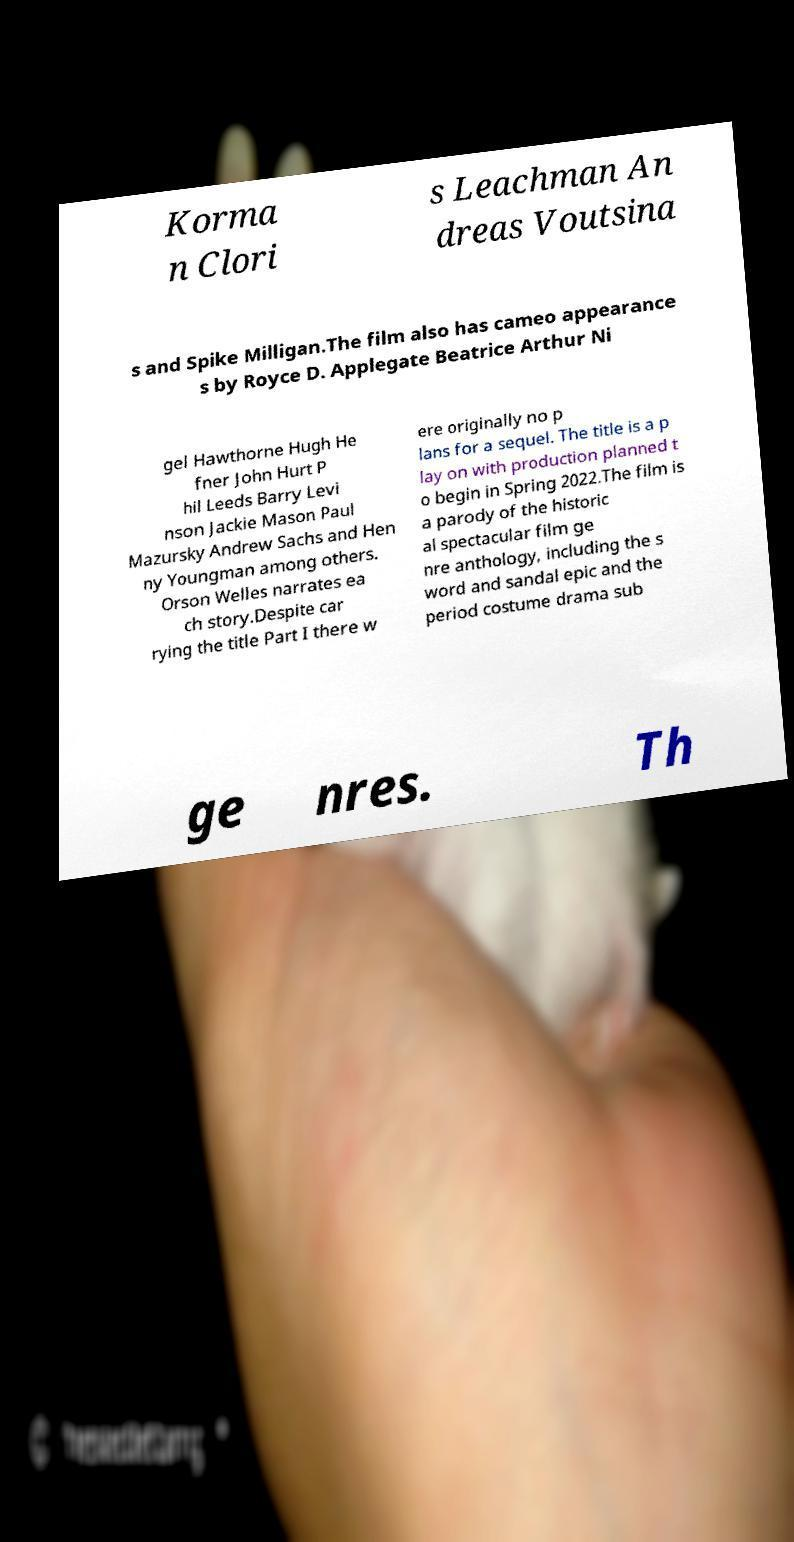What messages or text are displayed in this image? I need them in a readable, typed format. Korma n Clori s Leachman An dreas Voutsina s and Spike Milligan.The film also has cameo appearance s by Royce D. Applegate Beatrice Arthur Ni gel Hawthorne Hugh He fner John Hurt P hil Leeds Barry Levi nson Jackie Mason Paul Mazursky Andrew Sachs and Hen ny Youngman among others. Orson Welles narrates ea ch story.Despite car rying the title Part I there w ere originally no p lans for a sequel. The title is a p lay on with production planned t o begin in Spring 2022.The film is a parody of the historic al spectacular film ge nre anthology, including the s word and sandal epic and the period costume drama sub ge nres. Th 